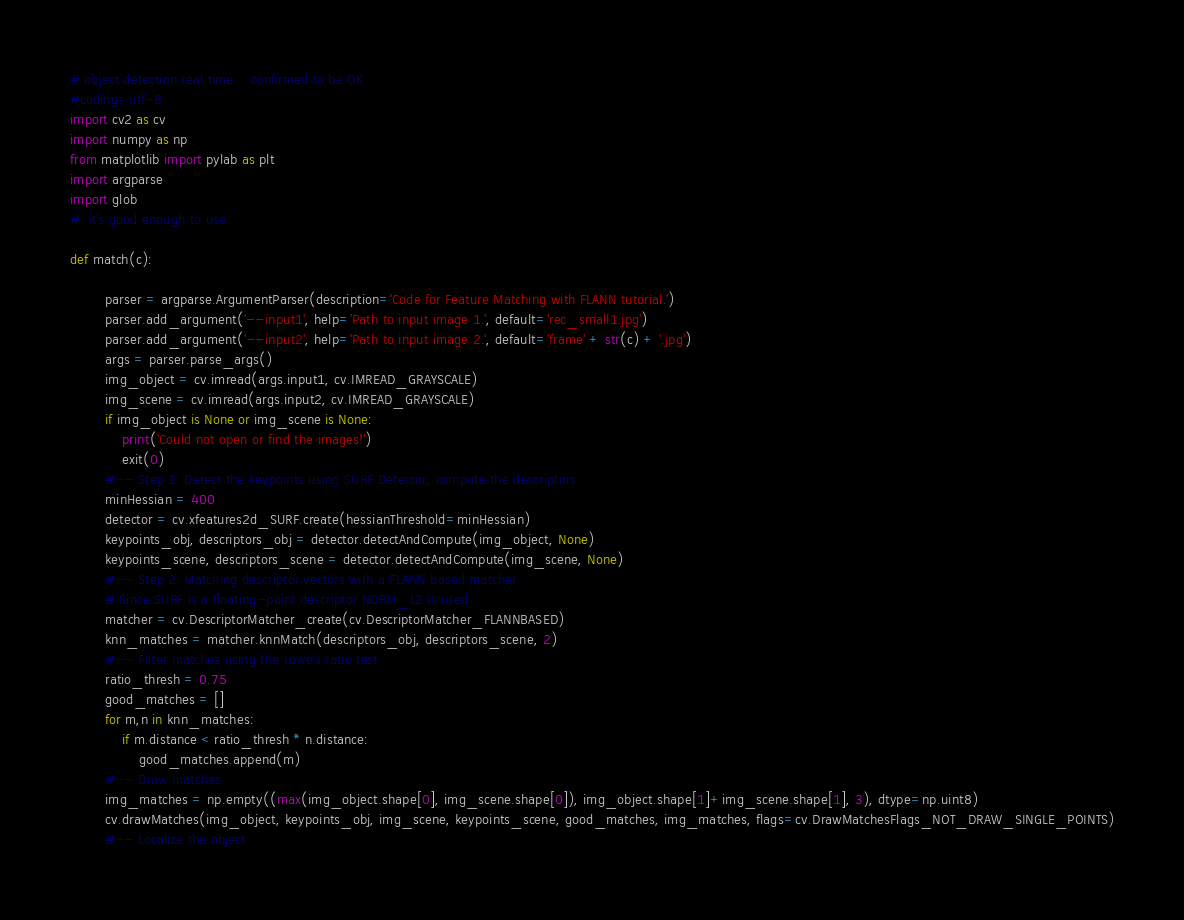Convert code to text. <code><loc_0><loc_0><loc_500><loc_500><_Python_># object detection real time    confirmed to be OK
#coding=utf-8 
import cv2 as cv
import numpy as np
from matplotlib import pylab as plt
import argparse
import glob
#  it's good enough to use

def match(c):

        parser = argparse.ArgumentParser(description='Code for Feature Matching with FLANN tutorial.')
        parser.add_argument('--input1', help='Path to input image 1.', default='rec_small1.jpg')
        parser.add_argument('--input2', help='Path to input image 2.', default='frame' + str(c) + '.jpg')
        args = parser.parse_args()
        img_object = cv.imread(args.input1, cv.IMREAD_GRAYSCALE)
        img_scene = cv.imread(args.input2, cv.IMREAD_GRAYSCALE)
        if img_object is None or img_scene is None:
            print('Could not open or find the images!')
            exit(0)
        #-- Step 1: Detect the keypoints using SURF Detector, compute the descriptors
        minHessian = 400
        detector = cv.xfeatures2d_SURF.create(hessianThreshold=minHessian)
        keypoints_obj, descriptors_obj = detector.detectAndCompute(img_object, None)
        keypoints_scene, descriptors_scene = detector.detectAndCompute(img_scene, None)
        #-- Step 2: Matching descriptor vectors with a FLANN based matcher
        # Since SURF is a floating-point descriptor NORM_L2 is used
        matcher = cv.DescriptorMatcher_create(cv.DescriptorMatcher_FLANNBASED)
        knn_matches = matcher.knnMatch(descriptors_obj, descriptors_scene, 2)
        #-- Filter matches using the Lowe's ratio test
        ratio_thresh = 0.75
        good_matches = []
        for m,n in knn_matches:
            if m.distance < ratio_thresh * n.distance:
                good_matches.append(m)
        #-- Draw matches
        img_matches = np.empty((max(img_object.shape[0], img_scene.shape[0]), img_object.shape[1]+img_scene.shape[1], 3), dtype=np.uint8)
        cv.drawMatches(img_object, keypoints_obj, img_scene, keypoints_scene, good_matches, img_matches, flags=cv.DrawMatchesFlags_NOT_DRAW_SINGLE_POINTS)
        #-- Localize the object</code> 